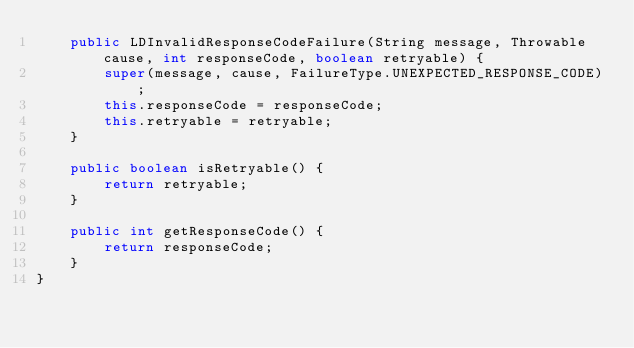<code> <loc_0><loc_0><loc_500><loc_500><_Java_>    public LDInvalidResponseCodeFailure(String message, Throwable cause, int responseCode, boolean retryable) {
        super(message, cause, FailureType.UNEXPECTED_RESPONSE_CODE);
        this.responseCode = responseCode;
        this.retryable = retryable;
    }

    public boolean isRetryable() {
        return retryable;
    }

    public int getResponseCode() {
        return responseCode;
    }
}</code> 